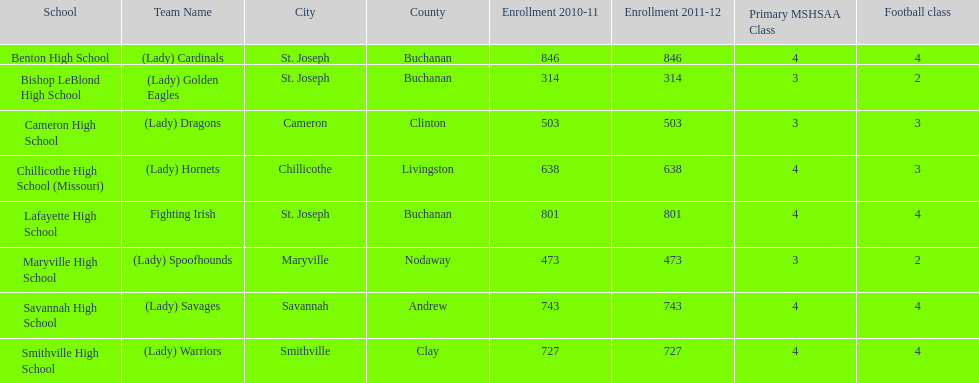I'm looking to parse the entire table for insights. Could you assist me with that? {'header': ['School', 'Team Name', 'City', 'County', 'Enrollment 2010-11', 'Enrollment 2011-12', 'Primary MSHSAA Class', 'Football class'], 'rows': [['Benton High School', '(Lady) Cardinals', 'St. Joseph', 'Buchanan', '846', '846', '4', '4'], ['Bishop LeBlond High School', '(Lady) Golden Eagles', 'St. Joseph', 'Buchanan', '314', '314', '3', '2'], ['Cameron High School', '(Lady) Dragons', 'Cameron', 'Clinton', '503', '503', '3', '3'], ['Chillicothe High School (Missouri)', '(Lady) Hornets', 'Chillicothe', 'Livingston', '638', '638', '4', '3'], ['Lafayette High School', 'Fighting Irish', 'St. Joseph', 'Buchanan', '801', '801', '4', '4'], ['Maryville High School', '(Lady) Spoofhounds', 'Maryville', 'Nodaway', '473', '473', '3', '2'], ['Savannah High School', '(Lady) Savages', 'Savannah', 'Andrew', '743', '743', '4', '4'], ['Smithville High School', '(Lady) Warriors', 'Smithville', 'Clay', '727', '727', '4', '4']]} How many schools are there in this conference? 8. 